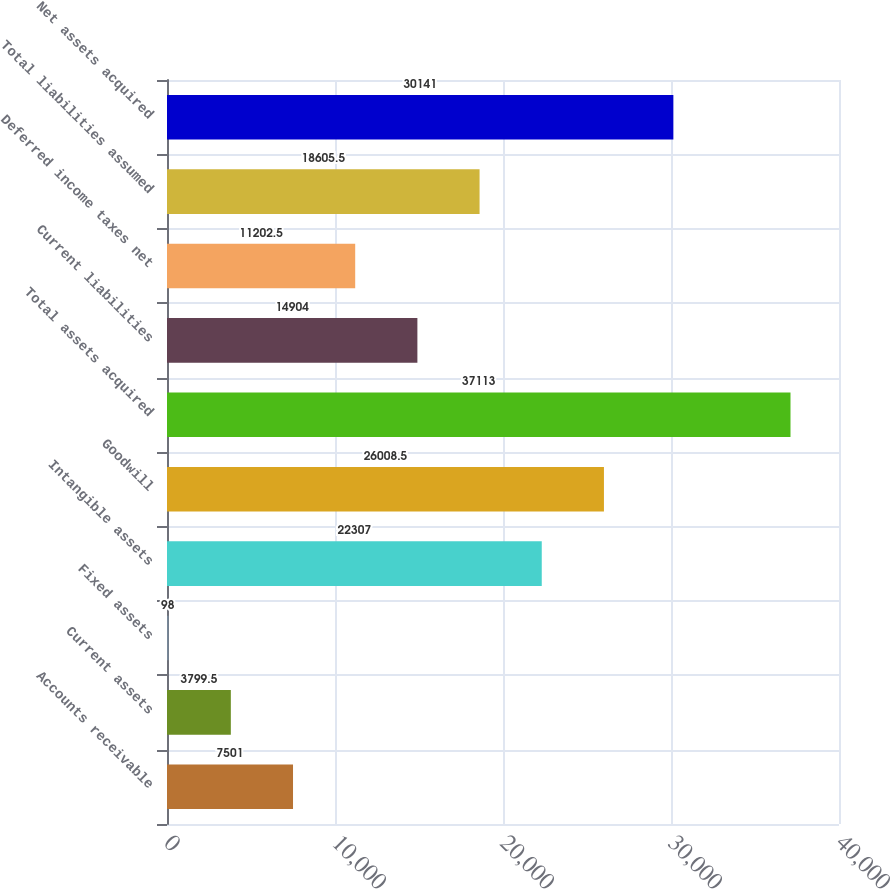Convert chart. <chart><loc_0><loc_0><loc_500><loc_500><bar_chart><fcel>Accounts receivable<fcel>Current assets<fcel>Fixed assets<fcel>Intangible assets<fcel>Goodwill<fcel>Total assets acquired<fcel>Current liabilities<fcel>Deferred income taxes net<fcel>Total liabilities assumed<fcel>Net assets acquired<nl><fcel>7501<fcel>3799.5<fcel>98<fcel>22307<fcel>26008.5<fcel>37113<fcel>14904<fcel>11202.5<fcel>18605.5<fcel>30141<nl></chart> 